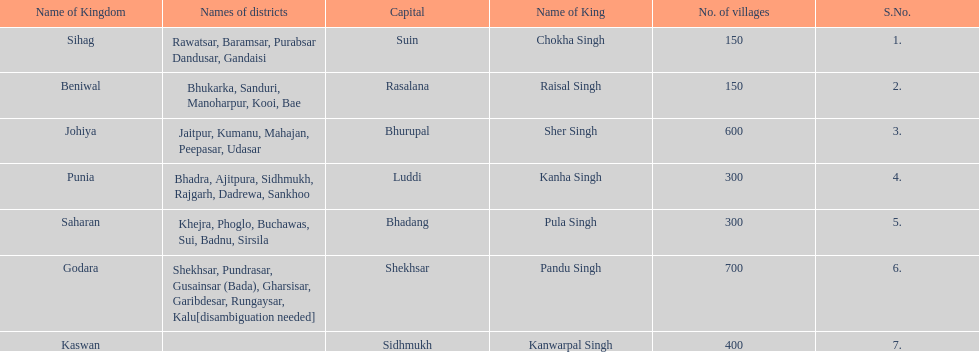What is the number of kingdoms that have more than 300 villages? 3. 